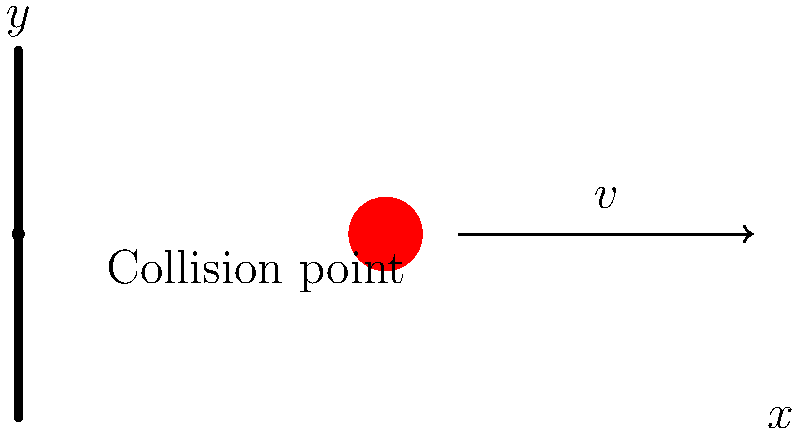During a cricket match, a ball traveling at velocity $v$ collides with a stationary wicket. Assuming the collision is perfectly elastic and the mass of the wicket is much greater than the mass of the ball, what is the velocity of the ball immediately after the collision? Let's approach this step-by-step:

1) In a perfectly elastic collision, both momentum and kinetic energy are conserved.

2) Given that the mass of the wicket is much greater than the mass of the ball, we can consider the wicket to be immovable during the collision.

3) In such a case, the collision can be treated as a one-dimensional elastic collision with a rigid, stationary surface.

4) For a one-dimensional elastic collision with a stationary surface, the velocity of the object after collision is equal in magnitude but opposite in direction to its velocity before collision.

5) Mathematically, if we denote the velocity after collision as $v'$, we can express this as:

   $$v' = -v$$

6) The negative sign indicates that the direction of the velocity has been reversed.

7) This result can also be derived from the conservation of energy and momentum principles:

   Momentum conservation: $mv = mv'$ (wicket doesn't move)
   Energy conservation: $\frac{1}{2}mv^2 = \frac{1}{2}mv'^2$

   Solving these equations leads to $v' = -v$.

8) Therefore, the ball will rebound from the wicket with the same speed it had before the collision, but in the opposite direction.
Answer: $-v$ 